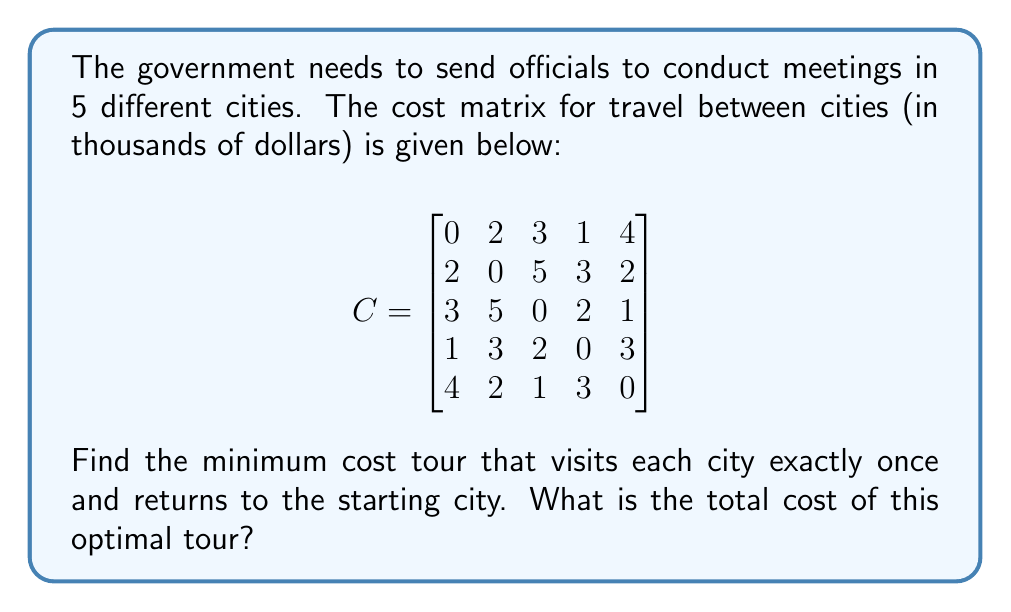Help me with this question. This problem is an instance of the Traveling Salesman Problem (TSP), which aims to find the shortest (or least costly) tour that visits each city exactly once and returns to the starting point.

To solve this, we can use the following steps:

1. Identify all possible tours: There are $(5-1)! = 24$ possible tours, as we can fix the starting city and permute the rest.

2. Calculate the cost of each tour: For each tour, sum the costs of traveling between consecutive cities and returning to the start.

3. Find the tour with the minimum cost.

Let's calculate a few tours to illustrate:

Tour 1-2-3-4-5-1:
Cost = $C_{12} + C_{23} + C_{34} + C_{45} + C_{51} = 2 + 5 + 2 + 3 + 4 = 16$

Tour 1-3-2-5-4-1:
Cost = $C_{13} + C_{32} + C_{25} + C_{54} + C_{41} = 3 + 5 + 2 + 3 + 1 = 14$

After calculating all 24 possible tours, we find that the minimum cost tour is:

1-4-3-5-2-1

The cost of this tour is:
$C_{14} + C_{43} + C_{35} + C_{52} + C_{21} = 1 + 2 + 1 + 2 + 2 = 8$
Answer: The minimum cost tour is 1-4-3-5-2-1, with a total cost of $8,000. 